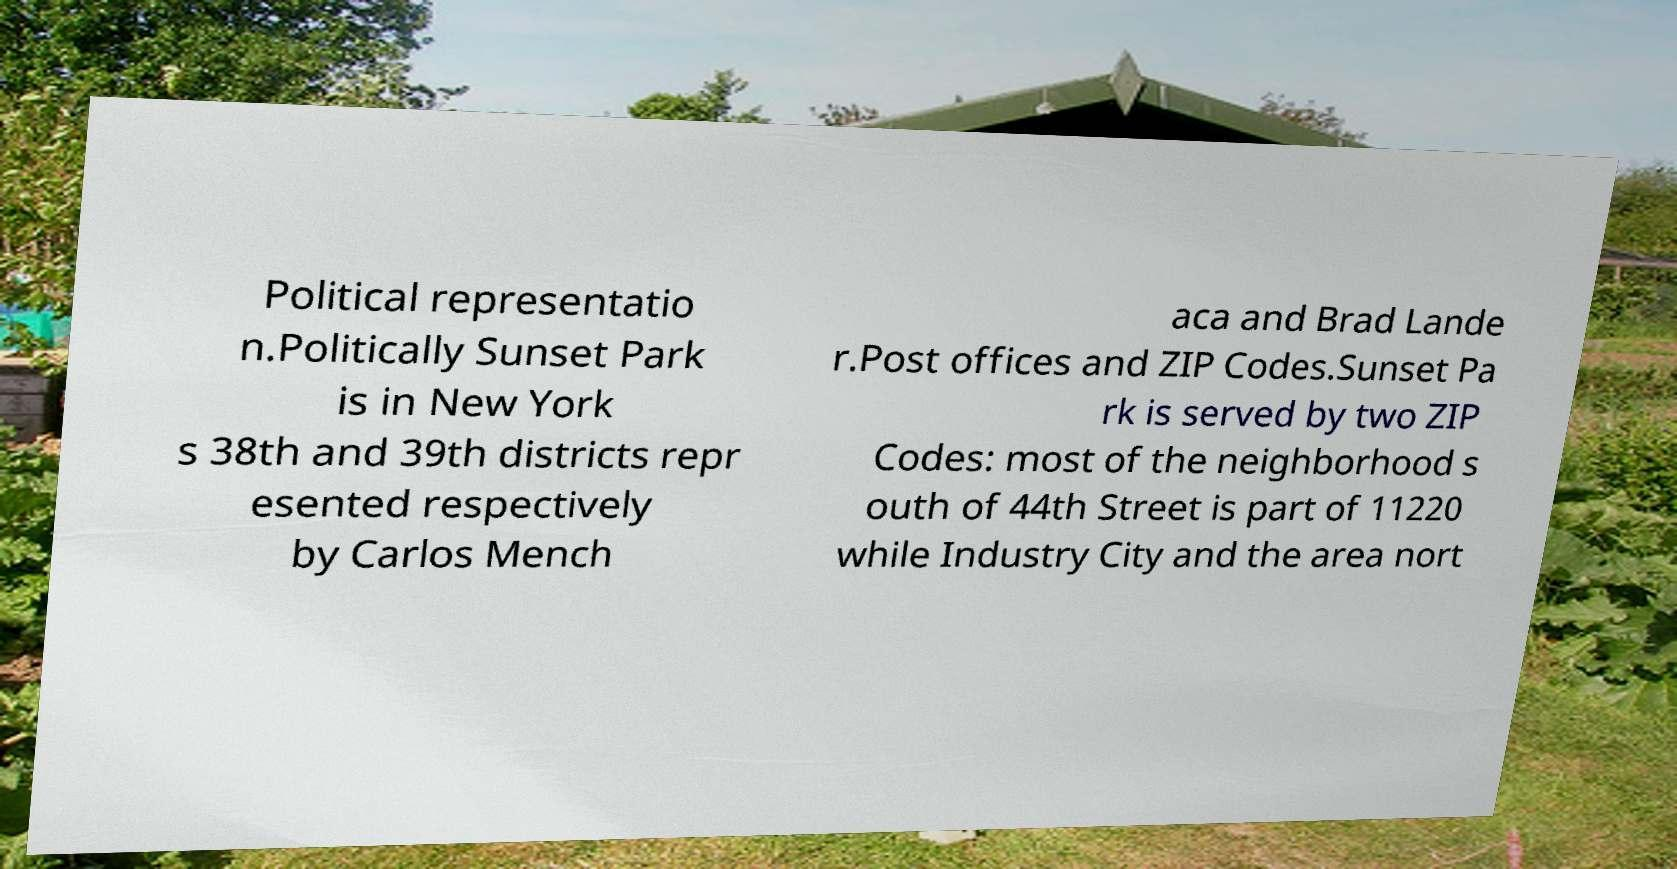Could you assist in decoding the text presented in this image and type it out clearly? Political representatio n.Politically Sunset Park is in New York s 38th and 39th districts repr esented respectively by Carlos Mench aca and Brad Lande r.Post offices and ZIP Codes.Sunset Pa rk is served by two ZIP Codes: most of the neighborhood s outh of 44th Street is part of 11220 while Industry City and the area nort 